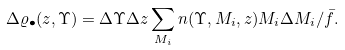<formula> <loc_0><loc_0><loc_500><loc_500>\Delta \varrho _ { \bullet } ( z , \Upsilon ) = \Delta \Upsilon \Delta z \sum _ { M _ { i } } n ( \Upsilon , M _ { i } , z ) M _ { i } \Delta M _ { i } / \bar { f } .</formula> 